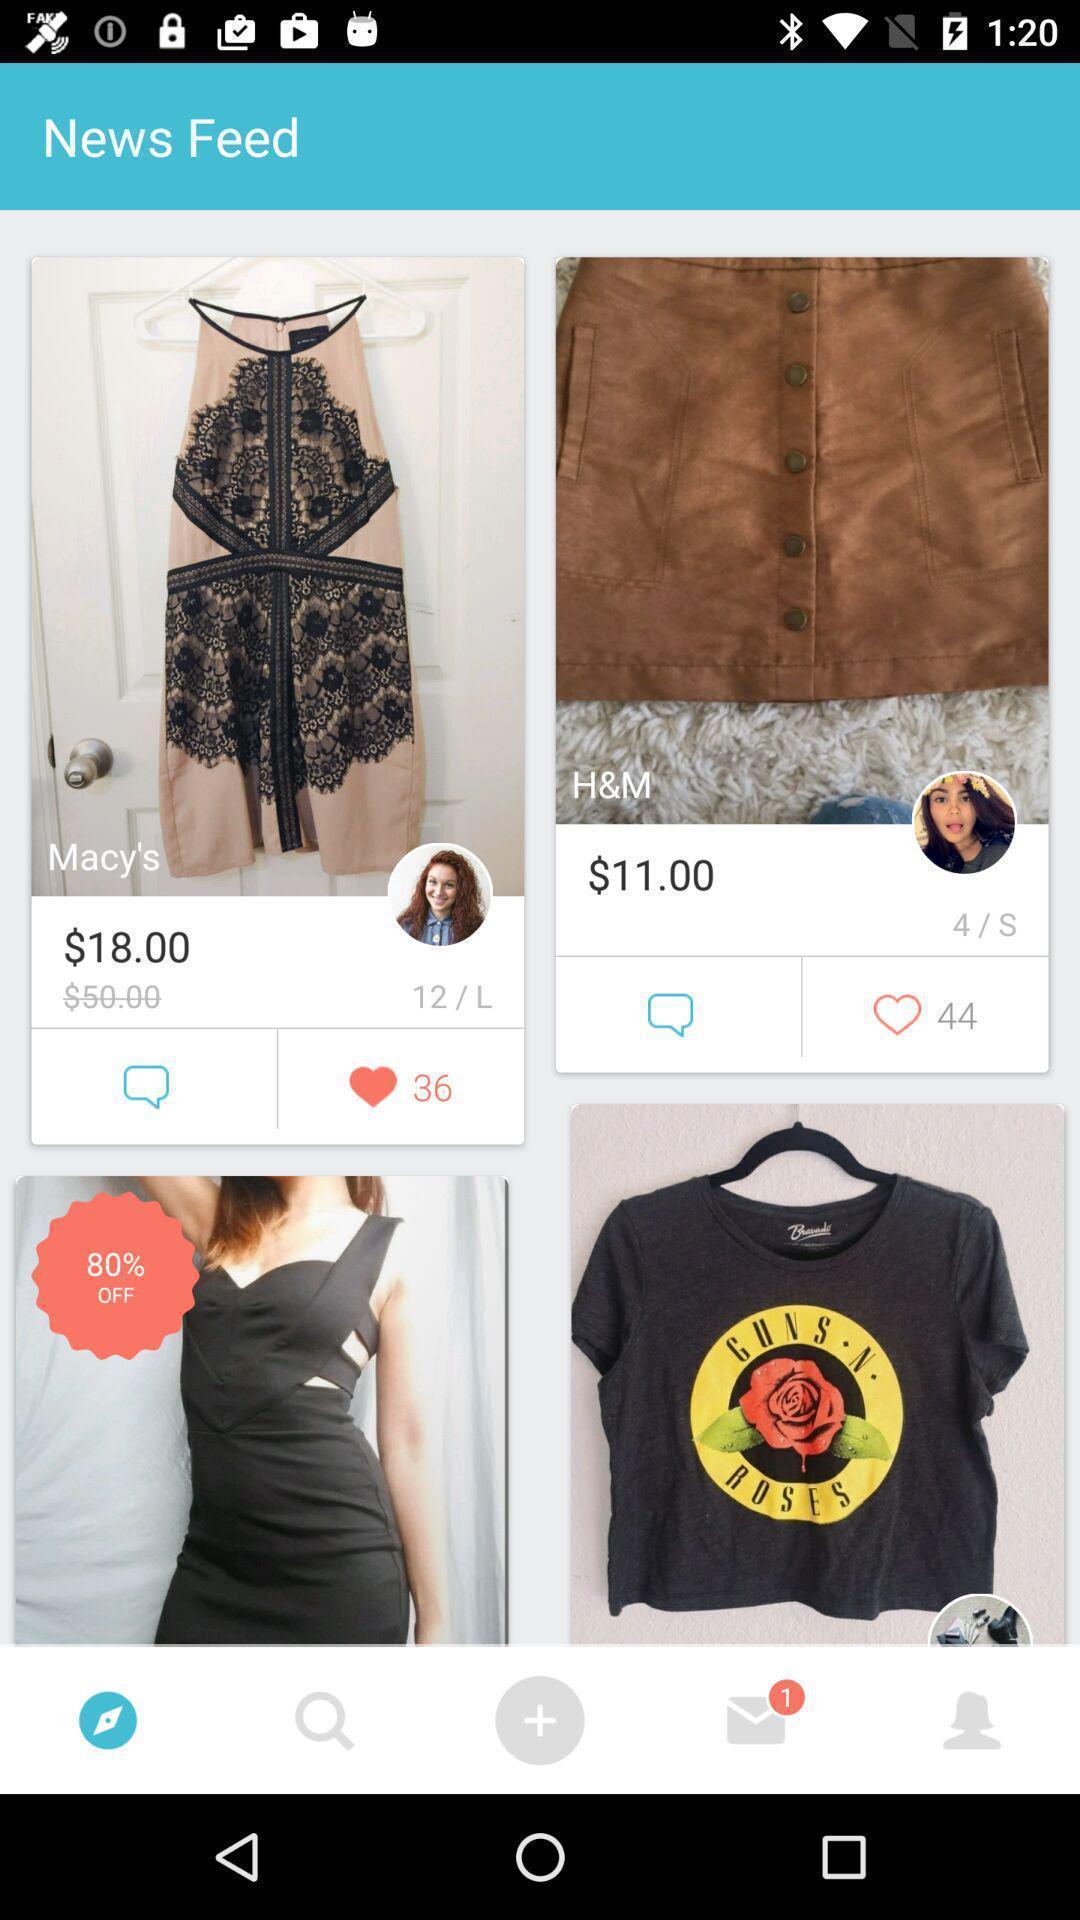Give me a narrative description of this picture. Screen showing list of various dress designs with price. 